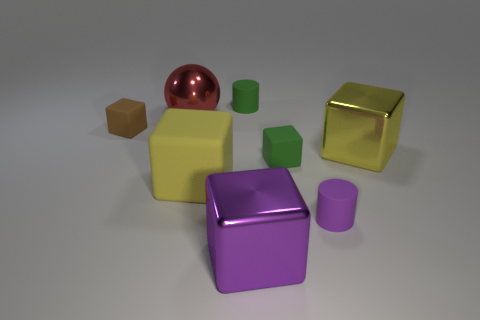There is a green cylinder that is the same size as the brown cube; what is it made of?
Ensure brevity in your answer.  Rubber. Are there the same number of large spheres behind the green cylinder and cubes that are in front of the purple block?
Keep it short and to the point. Yes. What number of cylinders are to the right of the purple metal object that is on the right side of the tiny rubber cylinder left of the small purple matte cylinder?
Your answer should be very brief. 1. Is the color of the metal ball the same as the metal block to the right of the small purple cylinder?
Ensure brevity in your answer.  No. There is a brown thing that is made of the same material as the green block; what size is it?
Keep it short and to the point. Small. Is the number of big purple things that are in front of the brown matte thing greater than the number of green matte cubes?
Provide a short and direct response. No. The large object right of the cylinder that is in front of the big yellow block that is on the left side of the purple metal object is made of what material?
Your response must be concise. Metal. Is the purple cylinder made of the same material as the yellow object behind the green cube?
Offer a terse response. No. There is another yellow thing that is the same shape as the yellow metallic object; what is it made of?
Offer a terse response. Rubber. Is there anything else that has the same material as the green cylinder?
Offer a terse response. Yes. 